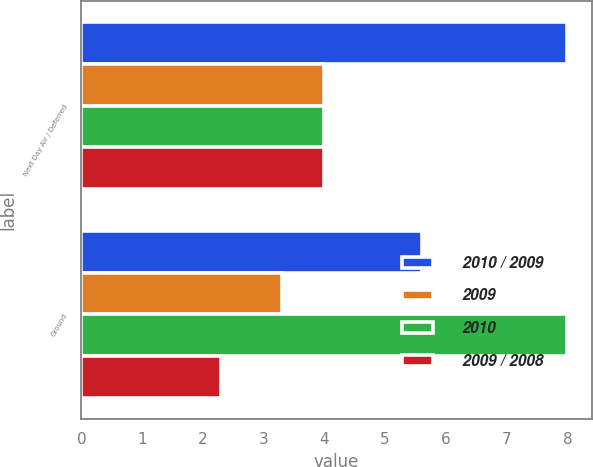Convert chart to OTSL. <chart><loc_0><loc_0><loc_500><loc_500><stacked_bar_chart><ecel><fcel>Next Day Air / Deferred<fcel>Ground<nl><fcel>2010 / 2009<fcel>8<fcel>5.6<nl><fcel>2009<fcel>4<fcel>3.3<nl><fcel>2010<fcel>4<fcel>8<nl><fcel>2009 / 2008<fcel>4<fcel>2.3<nl></chart> 